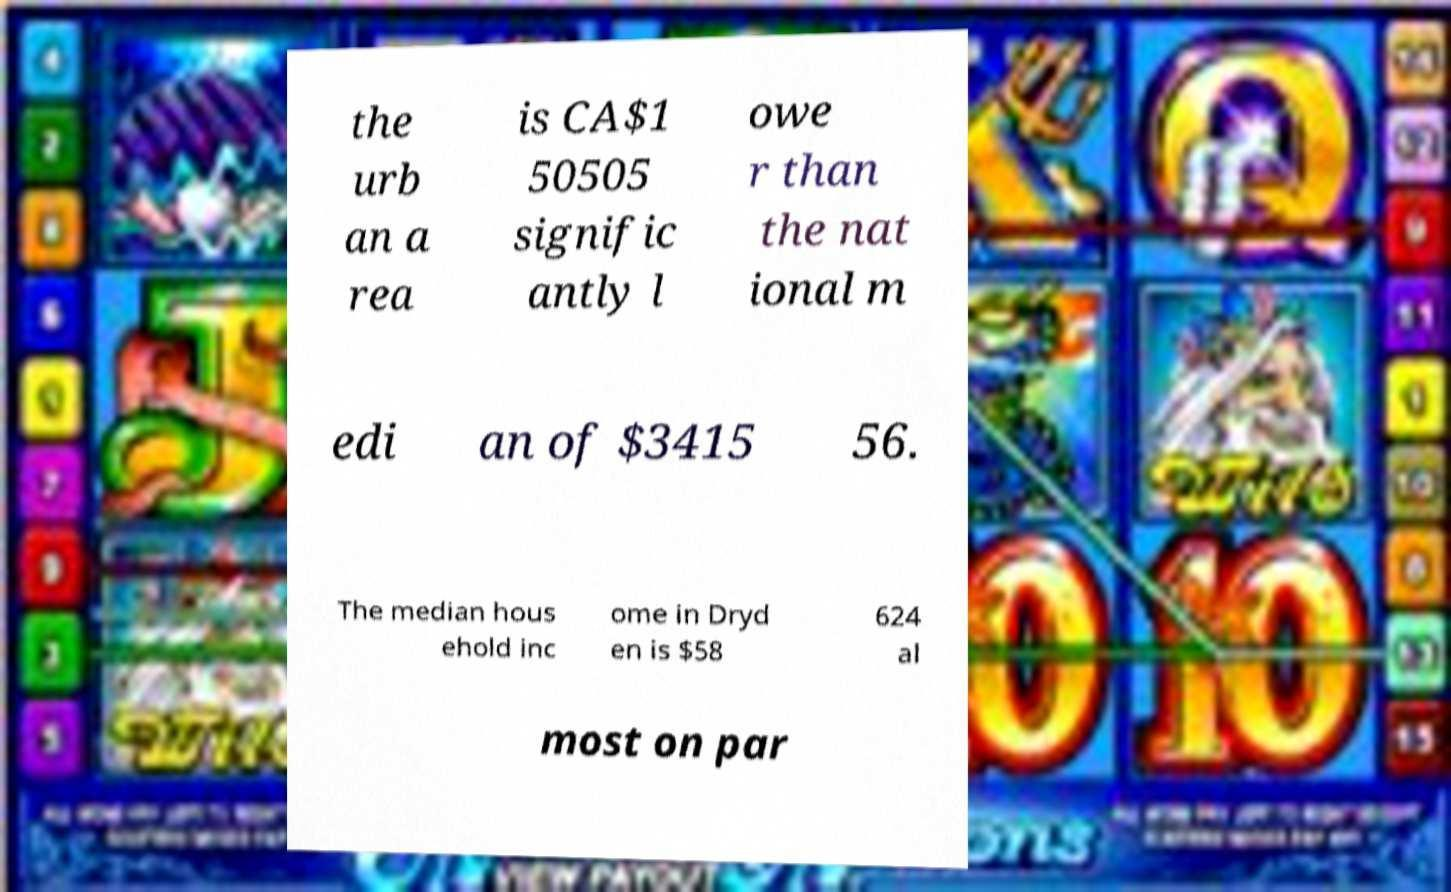Could you extract and type out the text from this image? the urb an a rea is CA$1 50505 signific antly l owe r than the nat ional m edi an of $3415 56. The median hous ehold inc ome in Dryd en is $58 624 al most on par 